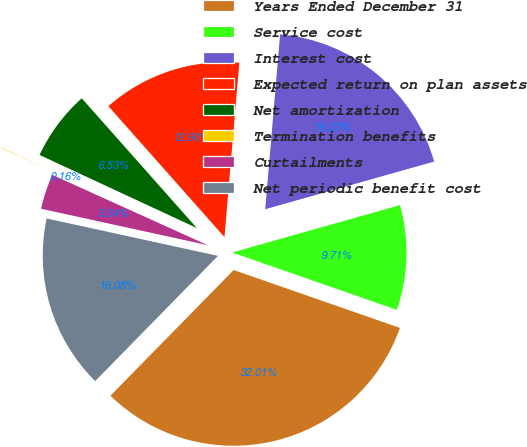Convert chart. <chart><loc_0><loc_0><loc_500><loc_500><pie_chart><fcel>Years Ended December 31<fcel>Service cost<fcel>Interest cost<fcel>Expected return on plan assets<fcel>Net amortization<fcel>Termination benefits<fcel>Curtailments<fcel>Net periodic benefit cost<nl><fcel>32.01%<fcel>9.71%<fcel>19.27%<fcel>12.9%<fcel>6.53%<fcel>0.16%<fcel>3.34%<fcel>16.08%<nl></chart> 